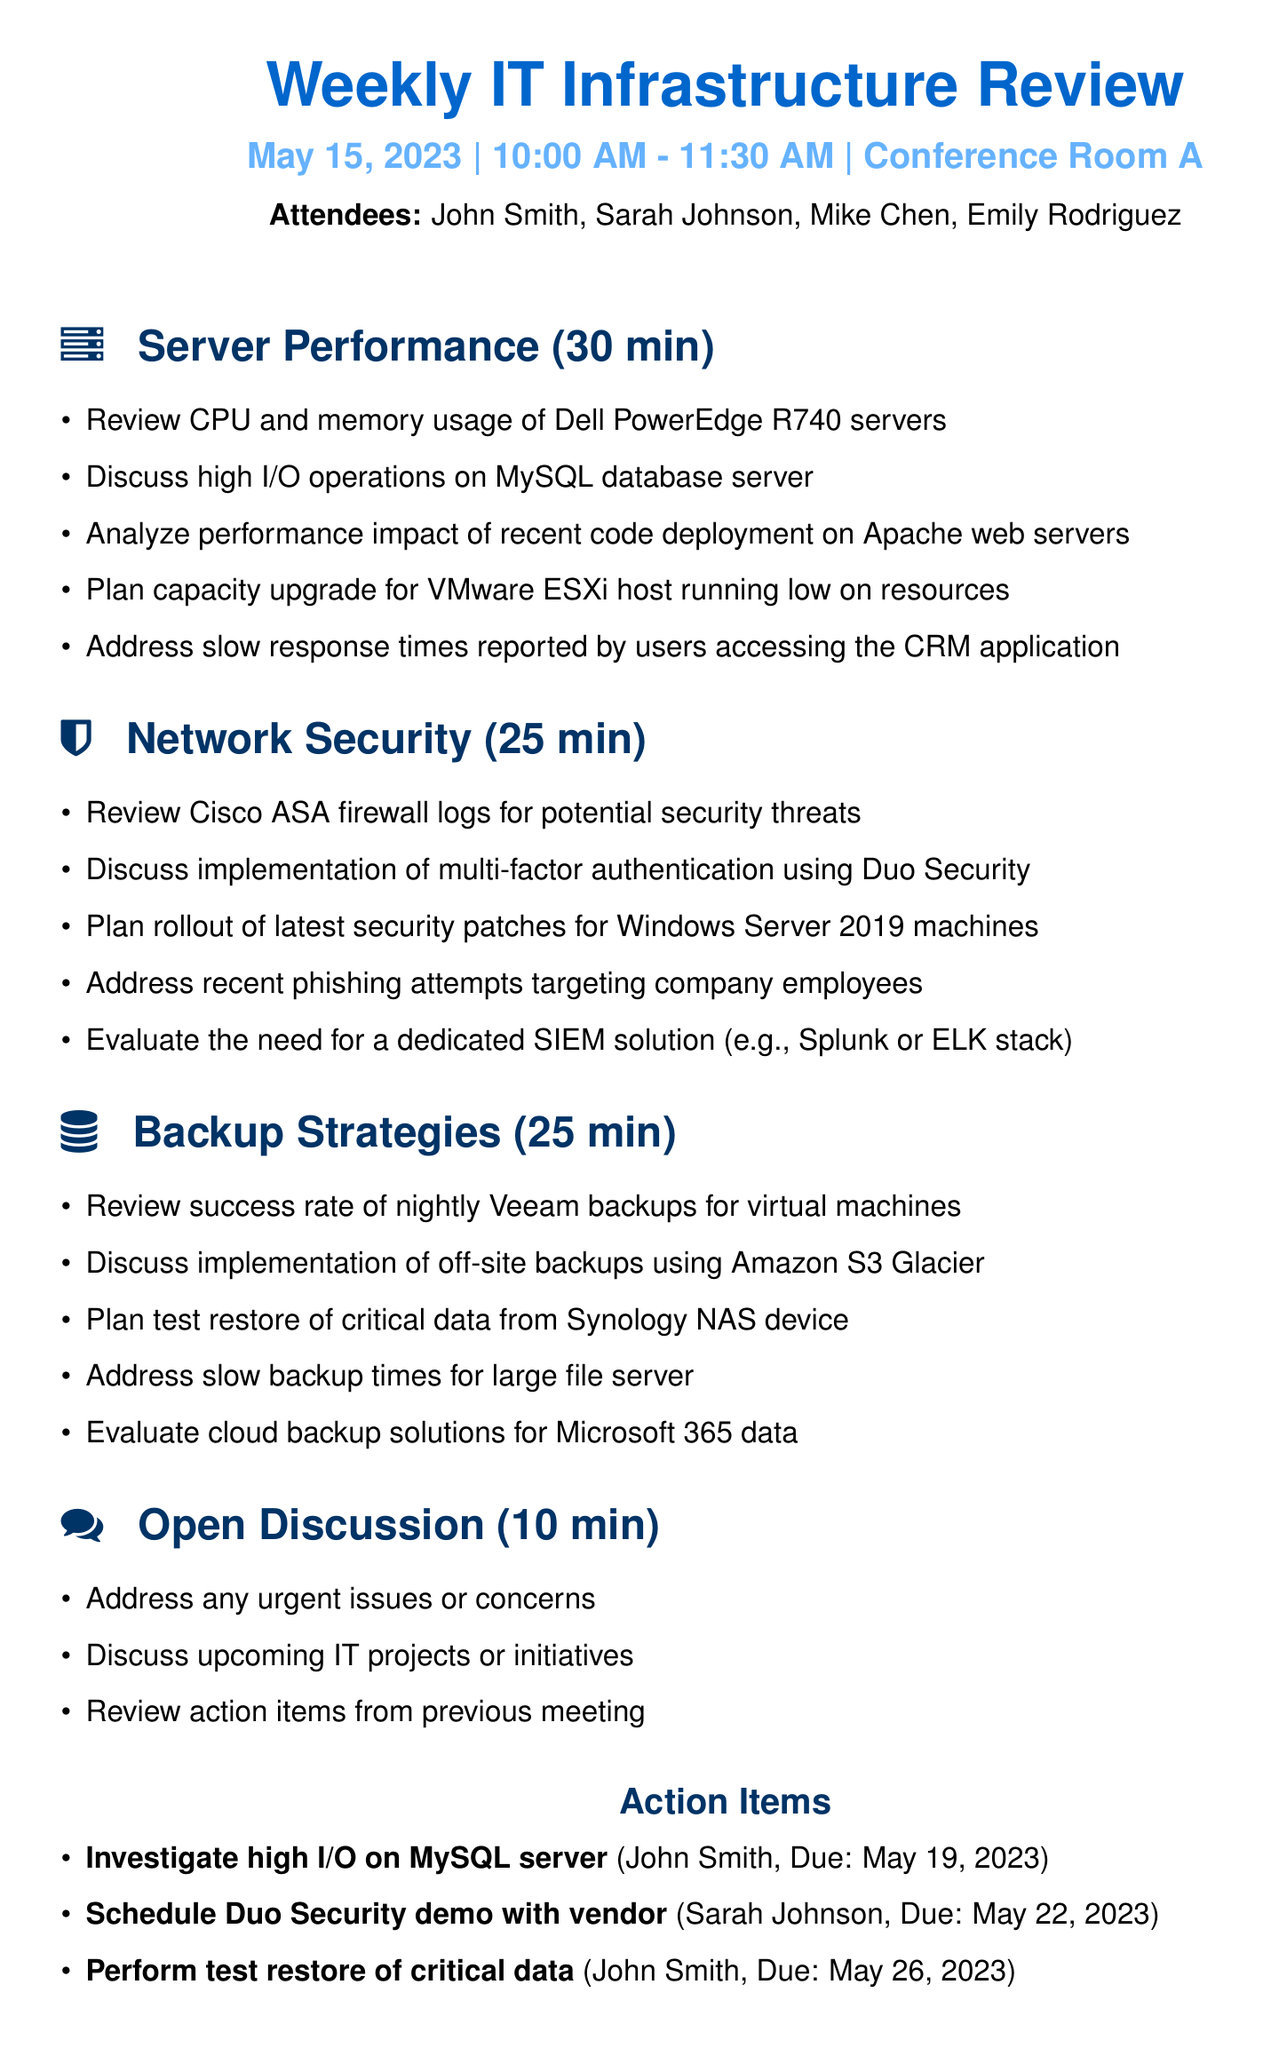What is the date of the meeting? The date of the meeting is explicitly mentioned in the document as May 15, 2023.
Answer: May 15, 2023 Who is the assignee for investigating high I/O on the MySQL server? The document lists action items, including the task to investigate high I/O on MySQL server assigned to John Smith.
Answer: John Smith How long is the discussion on Network Security scheduled for? The duration for the Network Security discussion is specified in the agenda items section as 25 minutes.
Answer: 25 minutes What is one of the discussion points under Backup Strategies? The discussion points for Backup Strategies include several items, one being the review of the success rate of nightly Veeam backups for virtual machines.
Answer: Review success rate of nightly Veeam backups for virtual machines What is the total duration of the agenda items listed? The individual durations for server performance, network security, backup strategies, and open discussion sum up to 90 minutes, covering the entire time of the meeting.
Answer: 90 minutes 